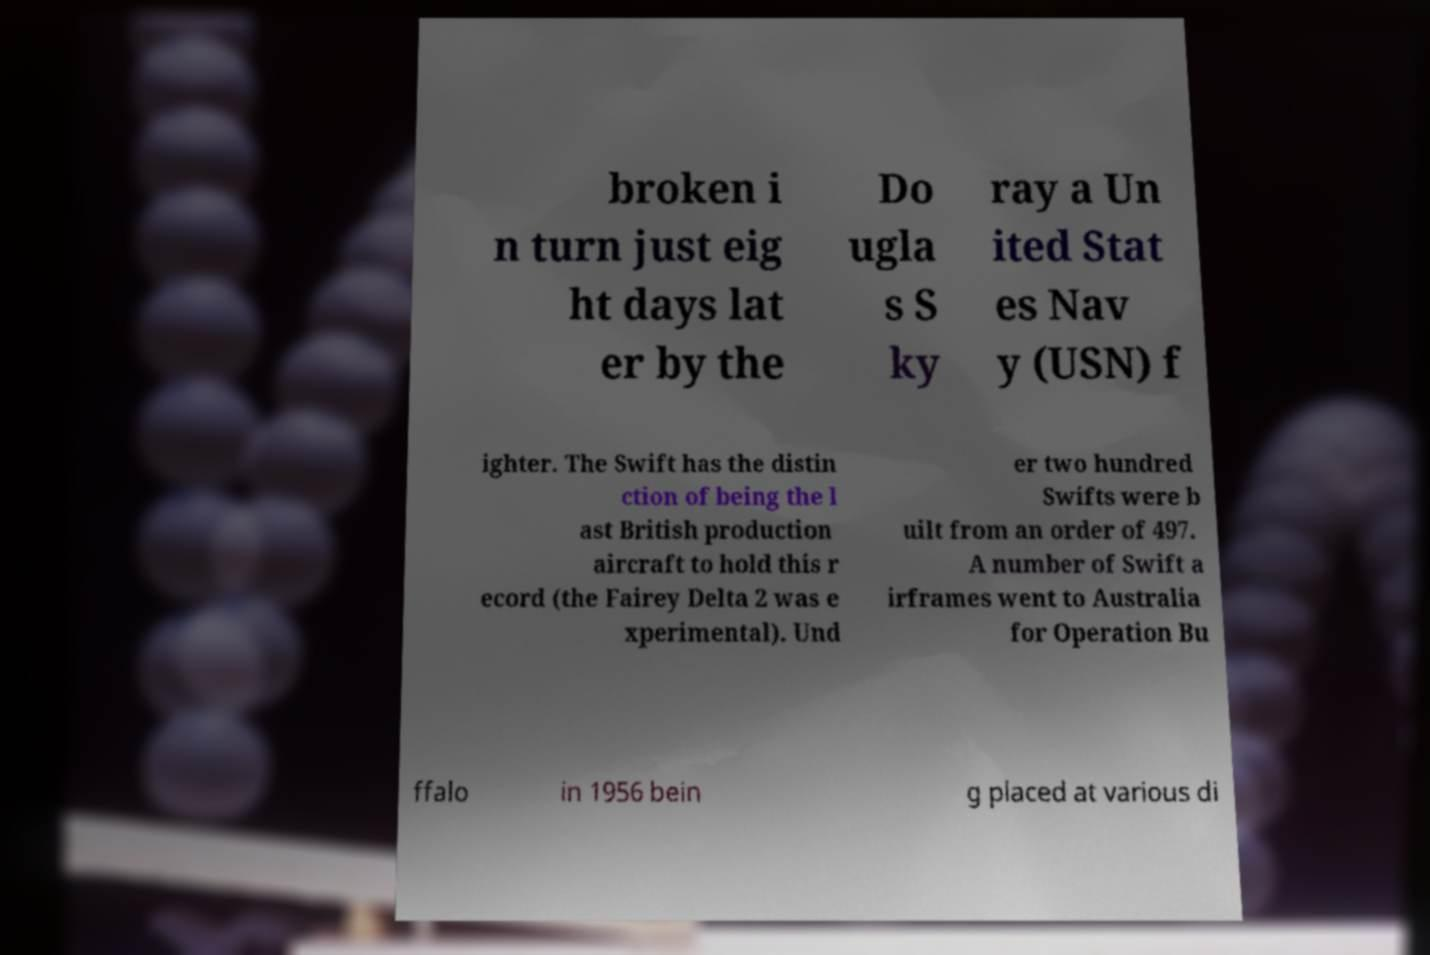There's text embedded in this image that I need extracted. Can you transcribe it verbatim? broken i n turn just eig ht days lat er by the Do ugla s S ky ray a Un ited Stat es Nav y (USN) f ighter. The Swift has the distin ction of being the l ast British production aircraft to hold this r ecord (the Fairey Delta 2 was e xperimental). Und er two hundred Swifts were b uilt from an order of 497. A number of Swift a irframes went to Australia for Operation Bu ffalo in 1956 bein g placed at various di 